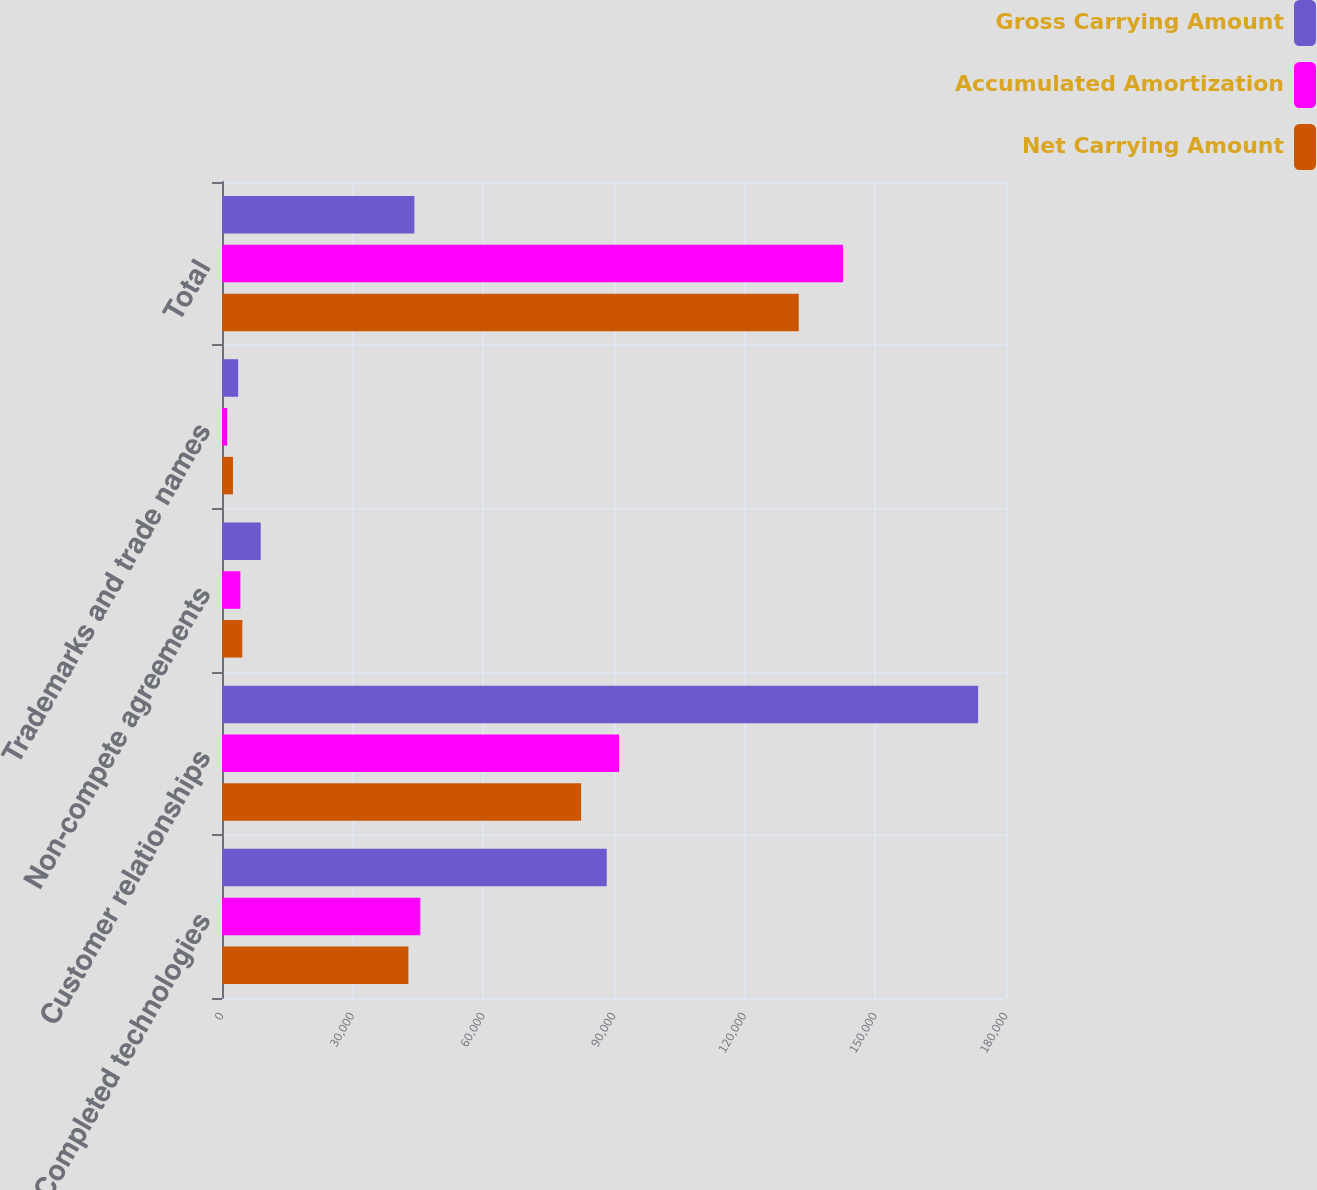<chart> <loc_0><loc_0><loc_500><loc_500><stacked_bar_chart><ecel><fcel>Completed technologies<fcel>Customer relationships<fcel>Non-compete agreements<fcel>Trademarks and trade names<fcel>Total<nl><fcel>Gross Carrying Amount<fcel>88331<fcel>173600<fcel>8890<fcel>3700<fcel>44165.5<nl><fcel>Accumulated Amortization<fcel>45537<fcel>91160<fcel>4224<fcel>1188<fcel>142599<nl><fcel>Net Carrying Amount<fcel>42794<fcel>82440<fcel>4666<fcel>2512<fcel>132412<nl></chart> 